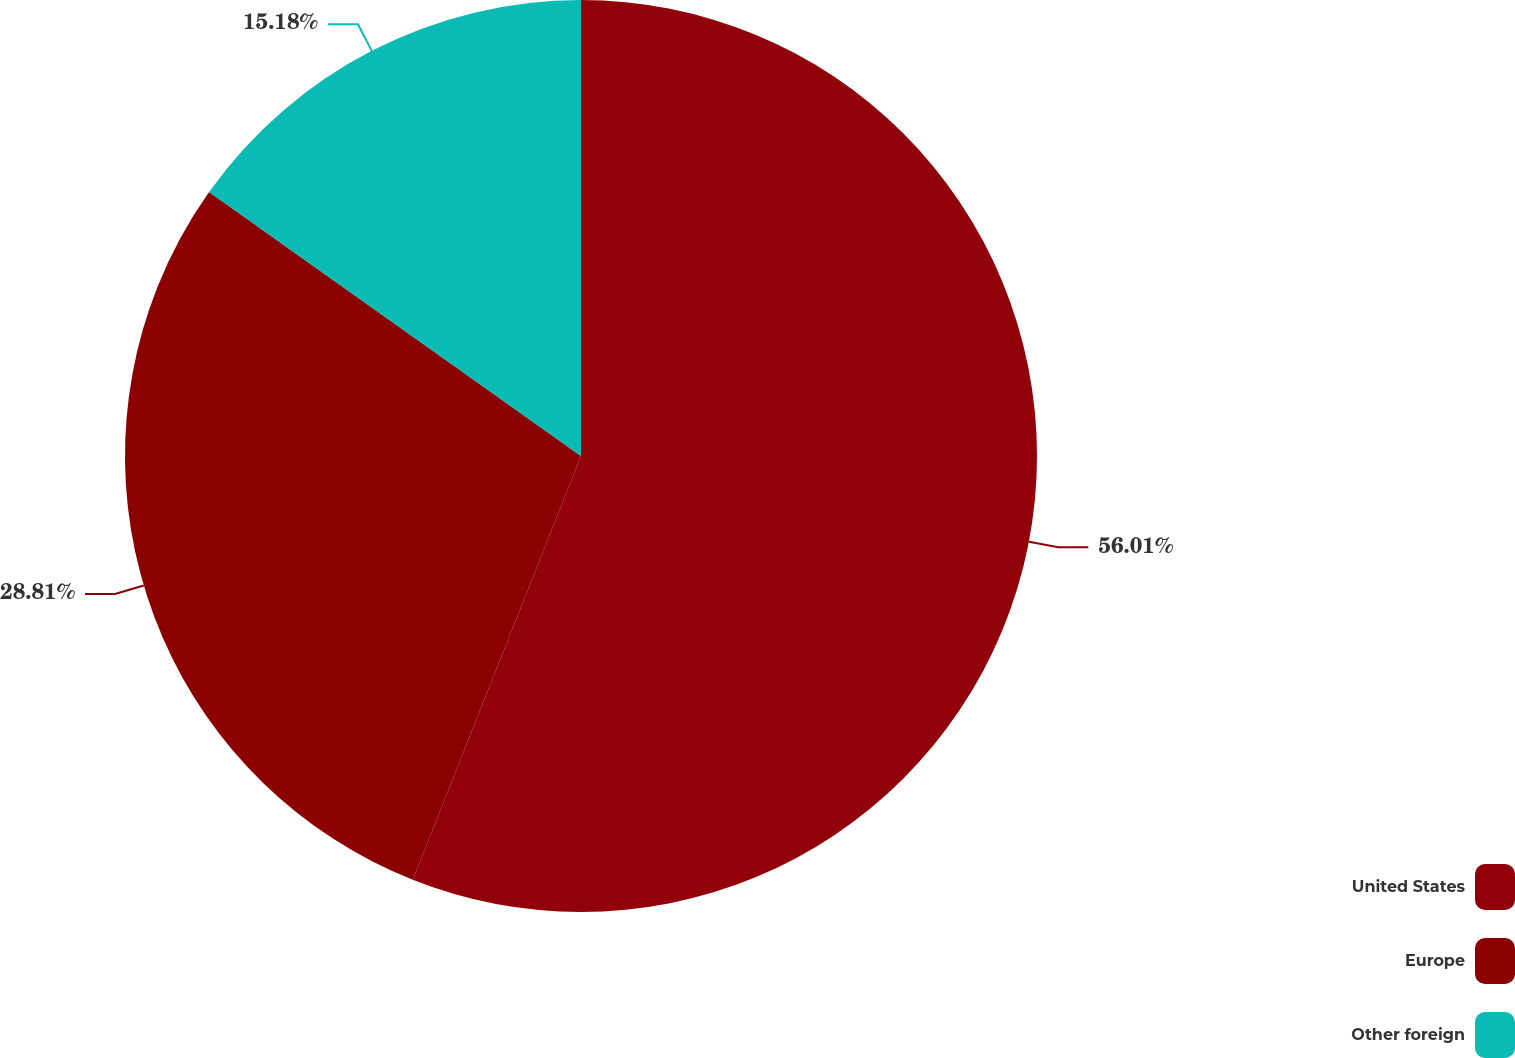Convert chart to OTSL. <chart><loc_0><loc_0><loc_500><loc_500><pie_chart><fcel>United States<fcel>Europe<fcel>Other foreign<nl><fcel>56.02%<fcel>28.81%<fcel>15.18%<nl></chart> 